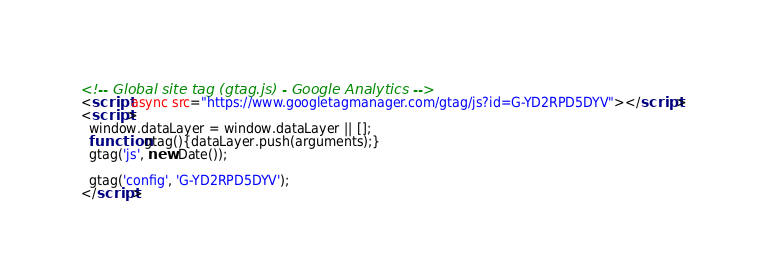Convert code to text. <code><loc_0><loc_0><loc_500><loc_500><_HTML_><!-- Global site tag (gtag.js) - Google Analytics -->
<script async src="https://www.googletagmanager.com/gtag/js?id=G-YD2RPD5DYV"></script>
<script>
  window.dataLayer = window.dataLayer || [];
  function gtag(){dataLayer.push(arguments);}
  gtag('js', new Date());

  gtag('config', 'G-YD2RPD5DYV');
</script>
</code> 